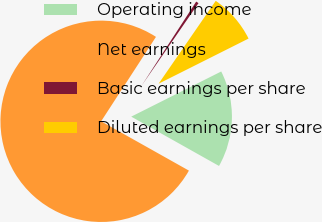<chart> <loc_0><loc_0><loc_500><loc_500><pie_chart><fcel>Operating income<fcel>Net earnings<fcel>Basic earnings per share<fcel>Diluted earnings per share<nl><fcel>15.55%<fcel>76.02%<fcel>0.44%<fcel>7.99%<nl></chart> 